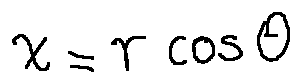Convert formula to latex. <formula><loc_0><loc_0><loc_500><loc_500>x = r \cos \theta</formula> 